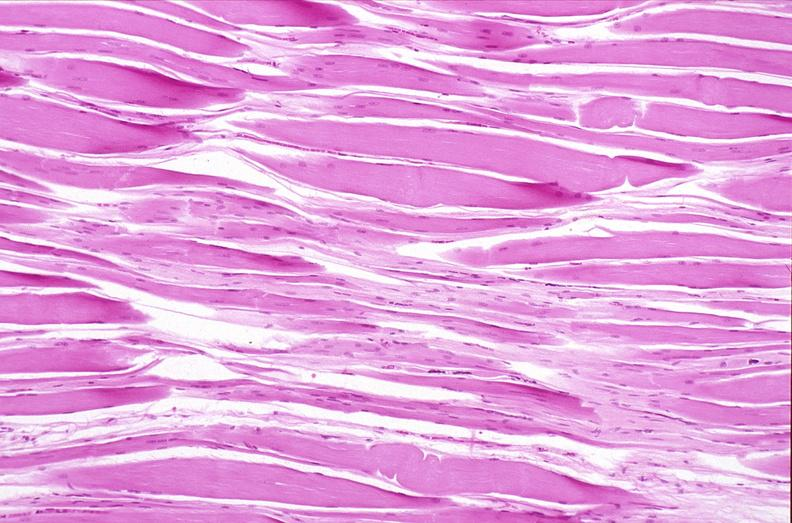s notochord present?
Answer the question using a single word or phrase. No 